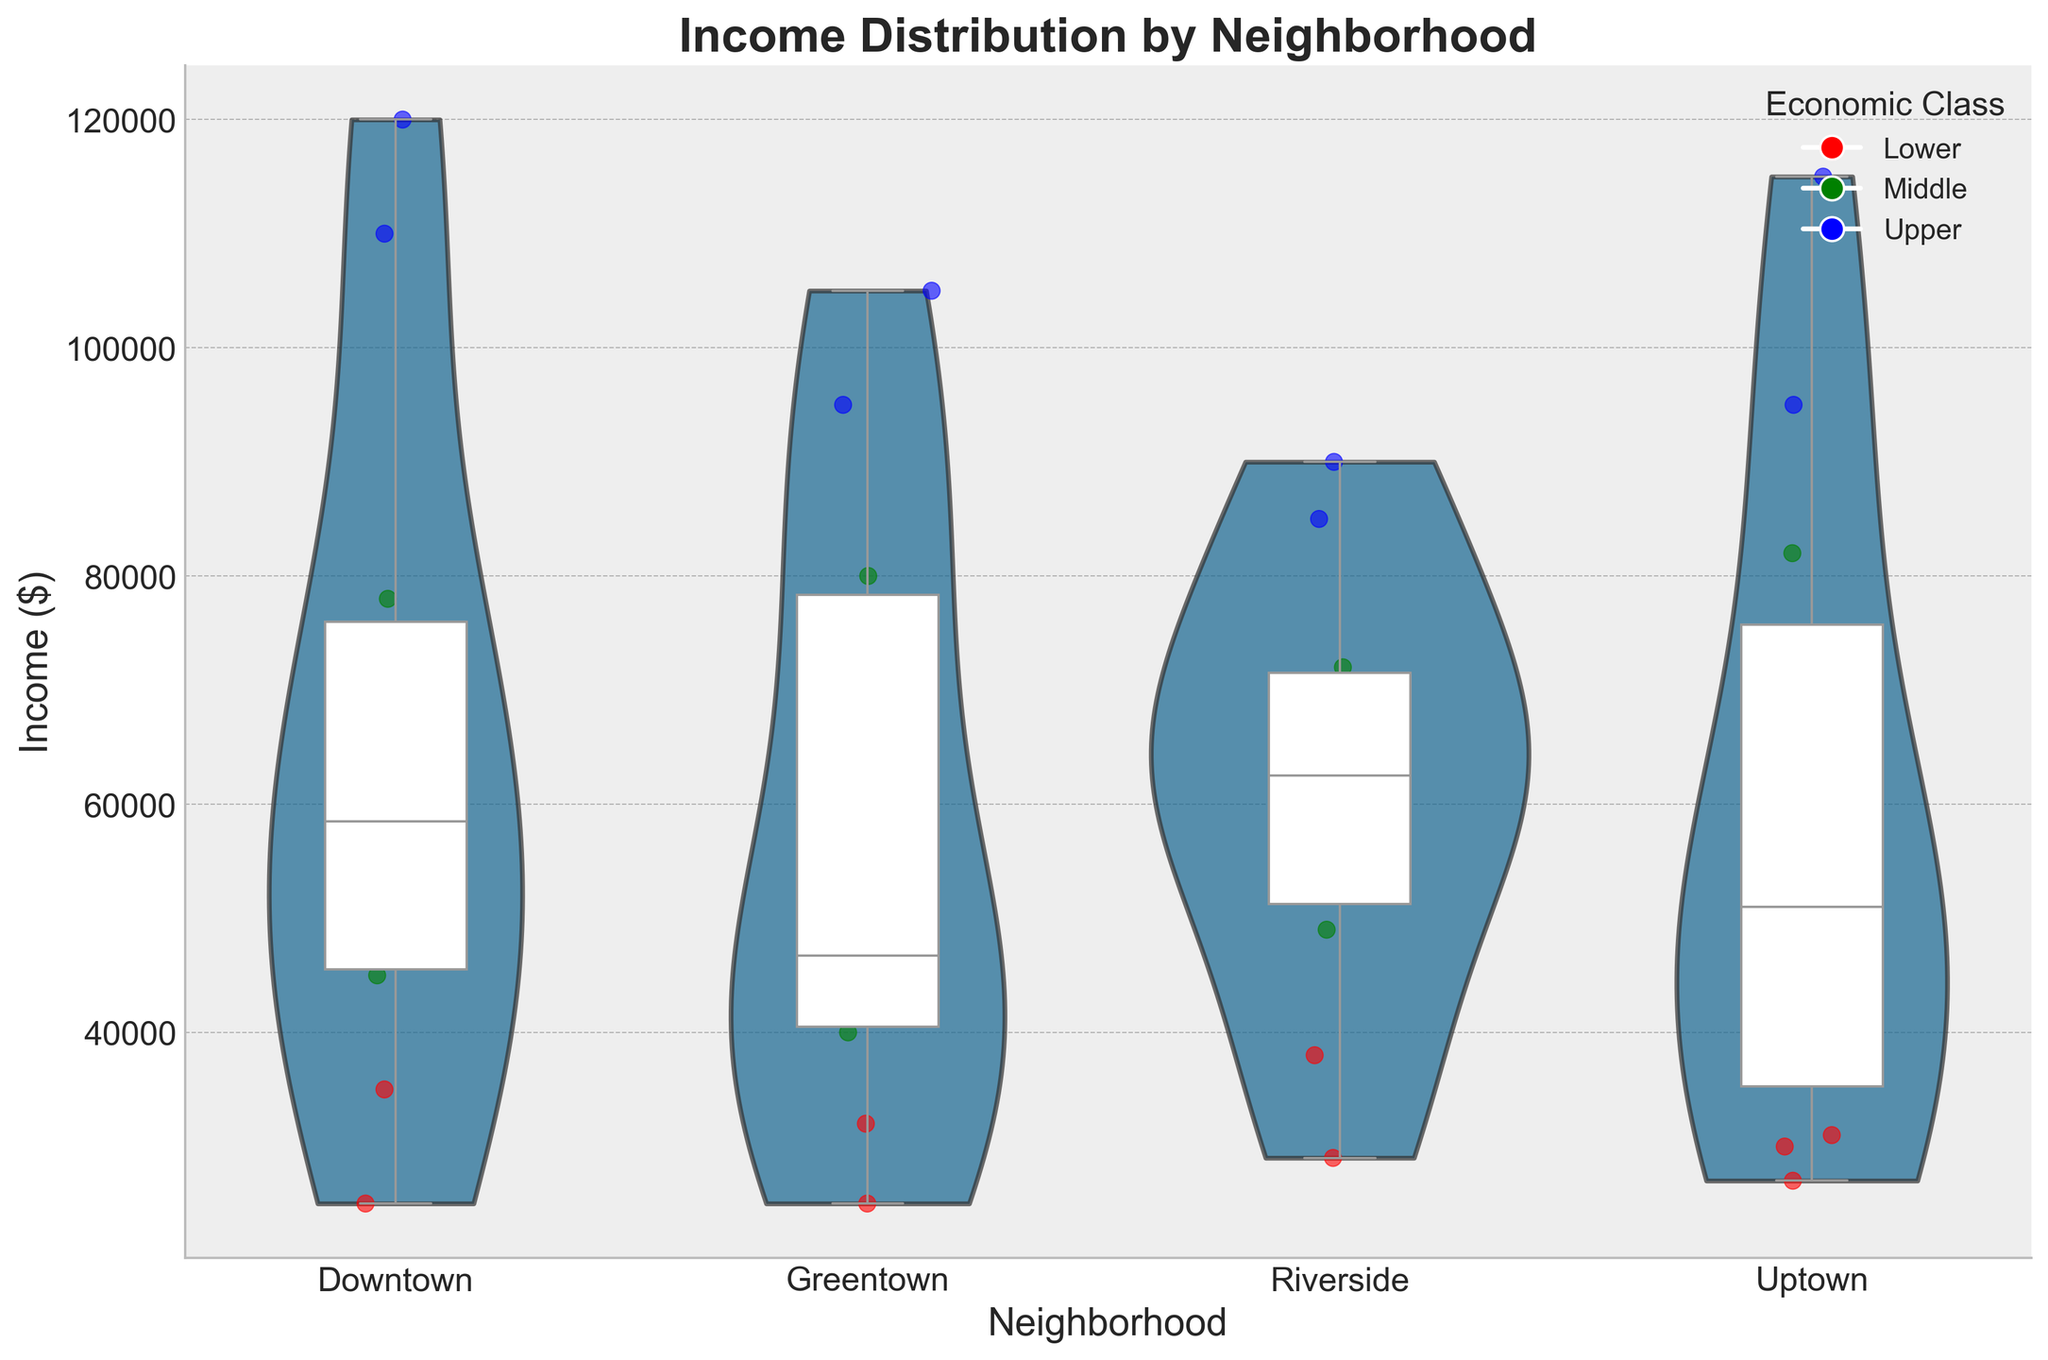What is the title of the chart? The title is positioned at the top of the chart and is in bold font.
Answer: Income Distribution by Neighborhood How is the income distributed in the Downtown neighborhood? The violin plot for Downtown reveals a broader spread, with more density around the middle-income range. The box plot illustrates the median, quartiles, and outliers within the same neighborhood.
Answer: Broad and centered around the middle-income range What colors represent the economic classes in the scatter plot overlay? Each economic class has a distinct color: red for Lower, green for Middle, and blue for Upper, as seen in the legend and the plotted points.
Answer: Red, green, and blue Which neighborhood appears to have the highest median income? By observing the white horizontal line inside the respective boxes of the box plots, we can compare median incomes. Neighbor scatter points can also provide insight.
Answer: Uptown What can you infer about income inequality in Riverside? The shape of the violin plot in Riverside shows a wide income distribution, implying significant inequality. The scattered points and box plot also show lower incomes mixed with high incomes.
Answer: High income inequality Which neighborhood has the most significant concentration of Upper-class incomes? The concentration of blue points (representing Upper-class incomes) within each violin plot can help identify this.
Answer: Downtown and Uptown Between Greentown and Riverside, which one has a higher number of lower-income data points? The number of red scatter points (representing Lower-class incomes) are visually compared between the neighborhoods of Greentown and Riverside.
Answer: Riverside What is the range of incomes for the Middle class in Downtown? The green points within the Downtown section represent the Middle class. Observing their spread from lowest to highest gives the income range.
Answer: $45,000 to $78,000 Is there any neighborhood where the income distribution is almost symmetrical? Symmetry in a violin plot suggests a balanced distribution. By comparing each plot's shape, we conclude if any appear balanced.
Answer: Uptown Based on the chart, which neighborhood would benefit the most from targeted economic policies? Observing which neighborhood shows the broadest and most uneven spread, with significant disparities across income classes, can inform this decision.
Answer: Riverside 